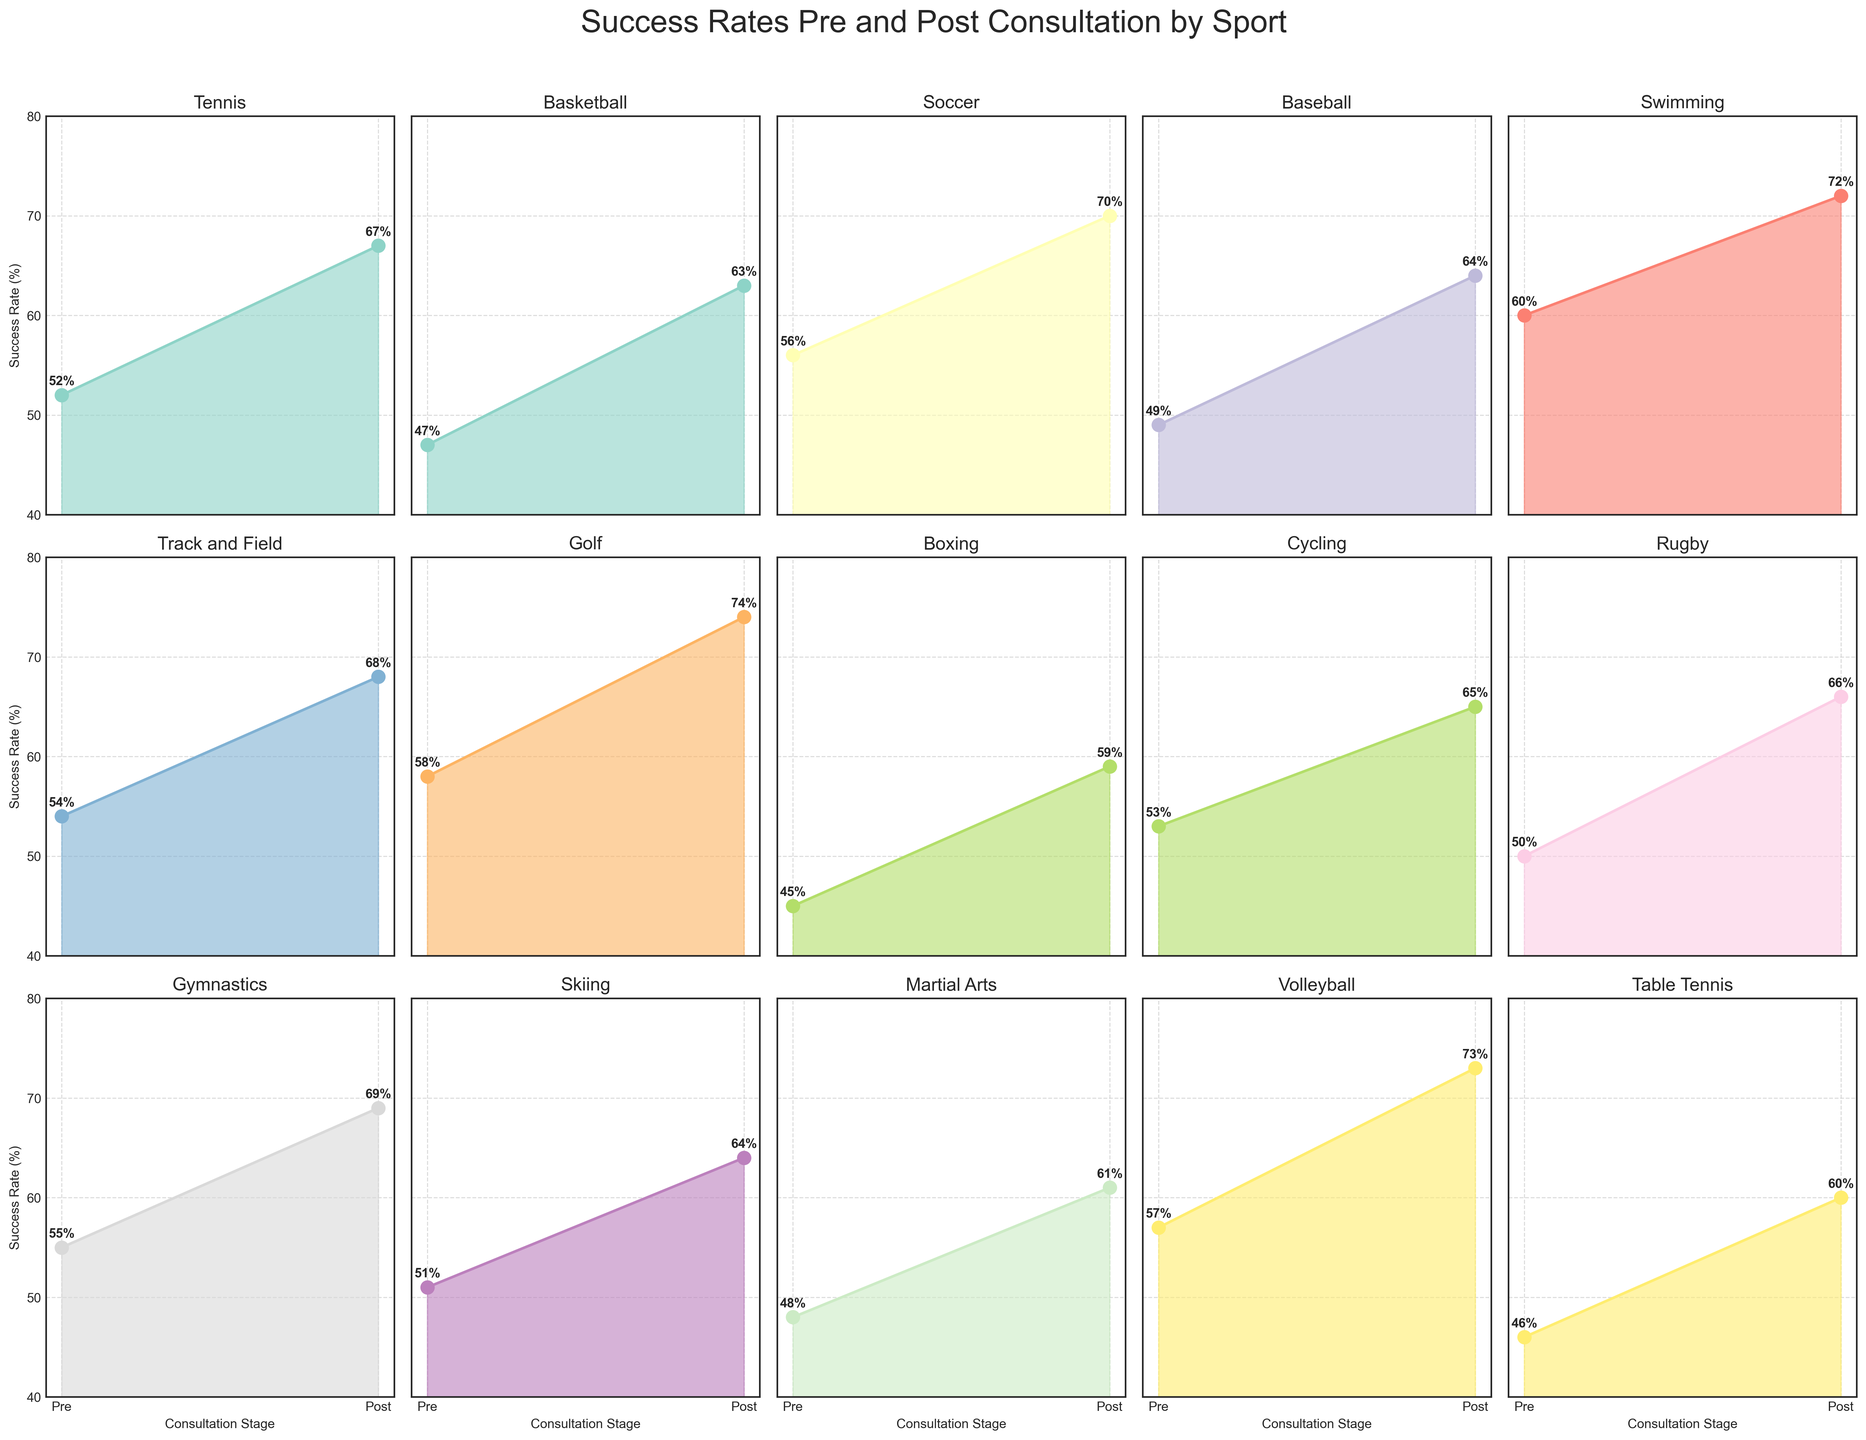What is the title of the figure? The title is typically positioned at the top of the figure. In this case, the code declares the title as "Success Rates Pre and Post Consultation by Sport".
Answer: Success Rates Pre and Post Consultation by Sport What are the two stages compared in each subplot? Looking at the x-axis labels of each subplot, the two stages compared are "Pre" and "Post".
Answer: Pre and Post Which sport shows the highest post-consultation success rate? By analyzing the post-consultation success rates in all the subplots, Golf has the highest post-consultation success rate of 74%.
Answer: Golf What is the difference in success rate for Tennis post-consultation? The success rate for Tennis pre-consultation is 52%, and post-consultation is 67%. The difference is found by subtracting 52 from 67.
Answer: 15% How many sports show an increase in success rate of more than 15% after consultation? To solve this, calculate the difference between post-consultation and pre-consultation success rates for each sport. Count the sports where this difference is greater than 15%. Sports that qualify are Tennis, Basketball, Soccer, Baseball, Swimming, Golf, Martial Arts, and Volleyball.
Answer: 8 sports Which sports have post-consultation success rates above 70%? By looking at each subplot's post-consultation success rates, the sports above 70% are Swimming, Golf, and Volleyball.
Answer: Swimming, Golf, Volleyball What is the median value of post-consultation success rates across all sports? Arrange the post-consultation success rates in ascending order: 59, 60, 61, 63, 64, 64, 65, 66, 67, 68, 69, 70, 72, 73, 74. The median value is the middle number in this ordered list.
Answer: 66% Which sport shows the smallest improvement in success rate post-consultation? By calculating the differences between pre and post-consultation success rates for each sport, Table Tennis has the smallest improvement of 14% (from 46% to 60%).
Answer: Table Tennis 